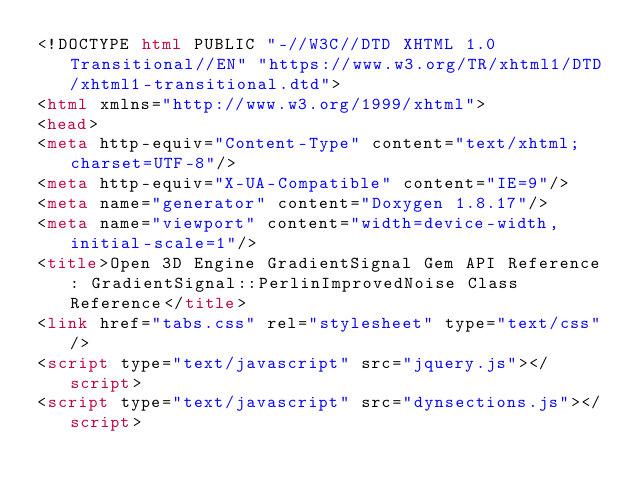<code> <loc_0><loc_0><loc_500><loc_500><_HTML_><!DOCTYPE html PUBLIC "-//W3C//DTD XHTML 1.0 Transitional//EN" "https://www.w3.org/TR/xhtml1/DTD/xhtml1-transitional.dtd">
<html xmlns="http://www.w3.org/1999/xhtml">
<head>
<meta http-equiv="Content-Type" content="text/xhtml;charset=UTF-8"/>
<meta http-equiv="X-UA-Compatible" content="IE=9"/>
<meta name="generator" content="Doxygen 1.8.17"/>
<meta name="viewport" content="width=device-width, initial-scale=1"/>
<title>Open 3D Engine GradientSignal Gem API Reference: GradientSignal::PerlinImprovedNoise Class Reference</title>
<link href="tabs.css" rel="stylesheet" type="text/css"/>
<script type="text/javascript" src="jquery.js"></script>
<script type="text/javascript" src="dynsections.js"></script></code> 